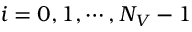<formula> <loc_0><loc_0><loc_500><loc_500>i = 0 , 1 , \cdots , N _ { V } - 1</formula> 